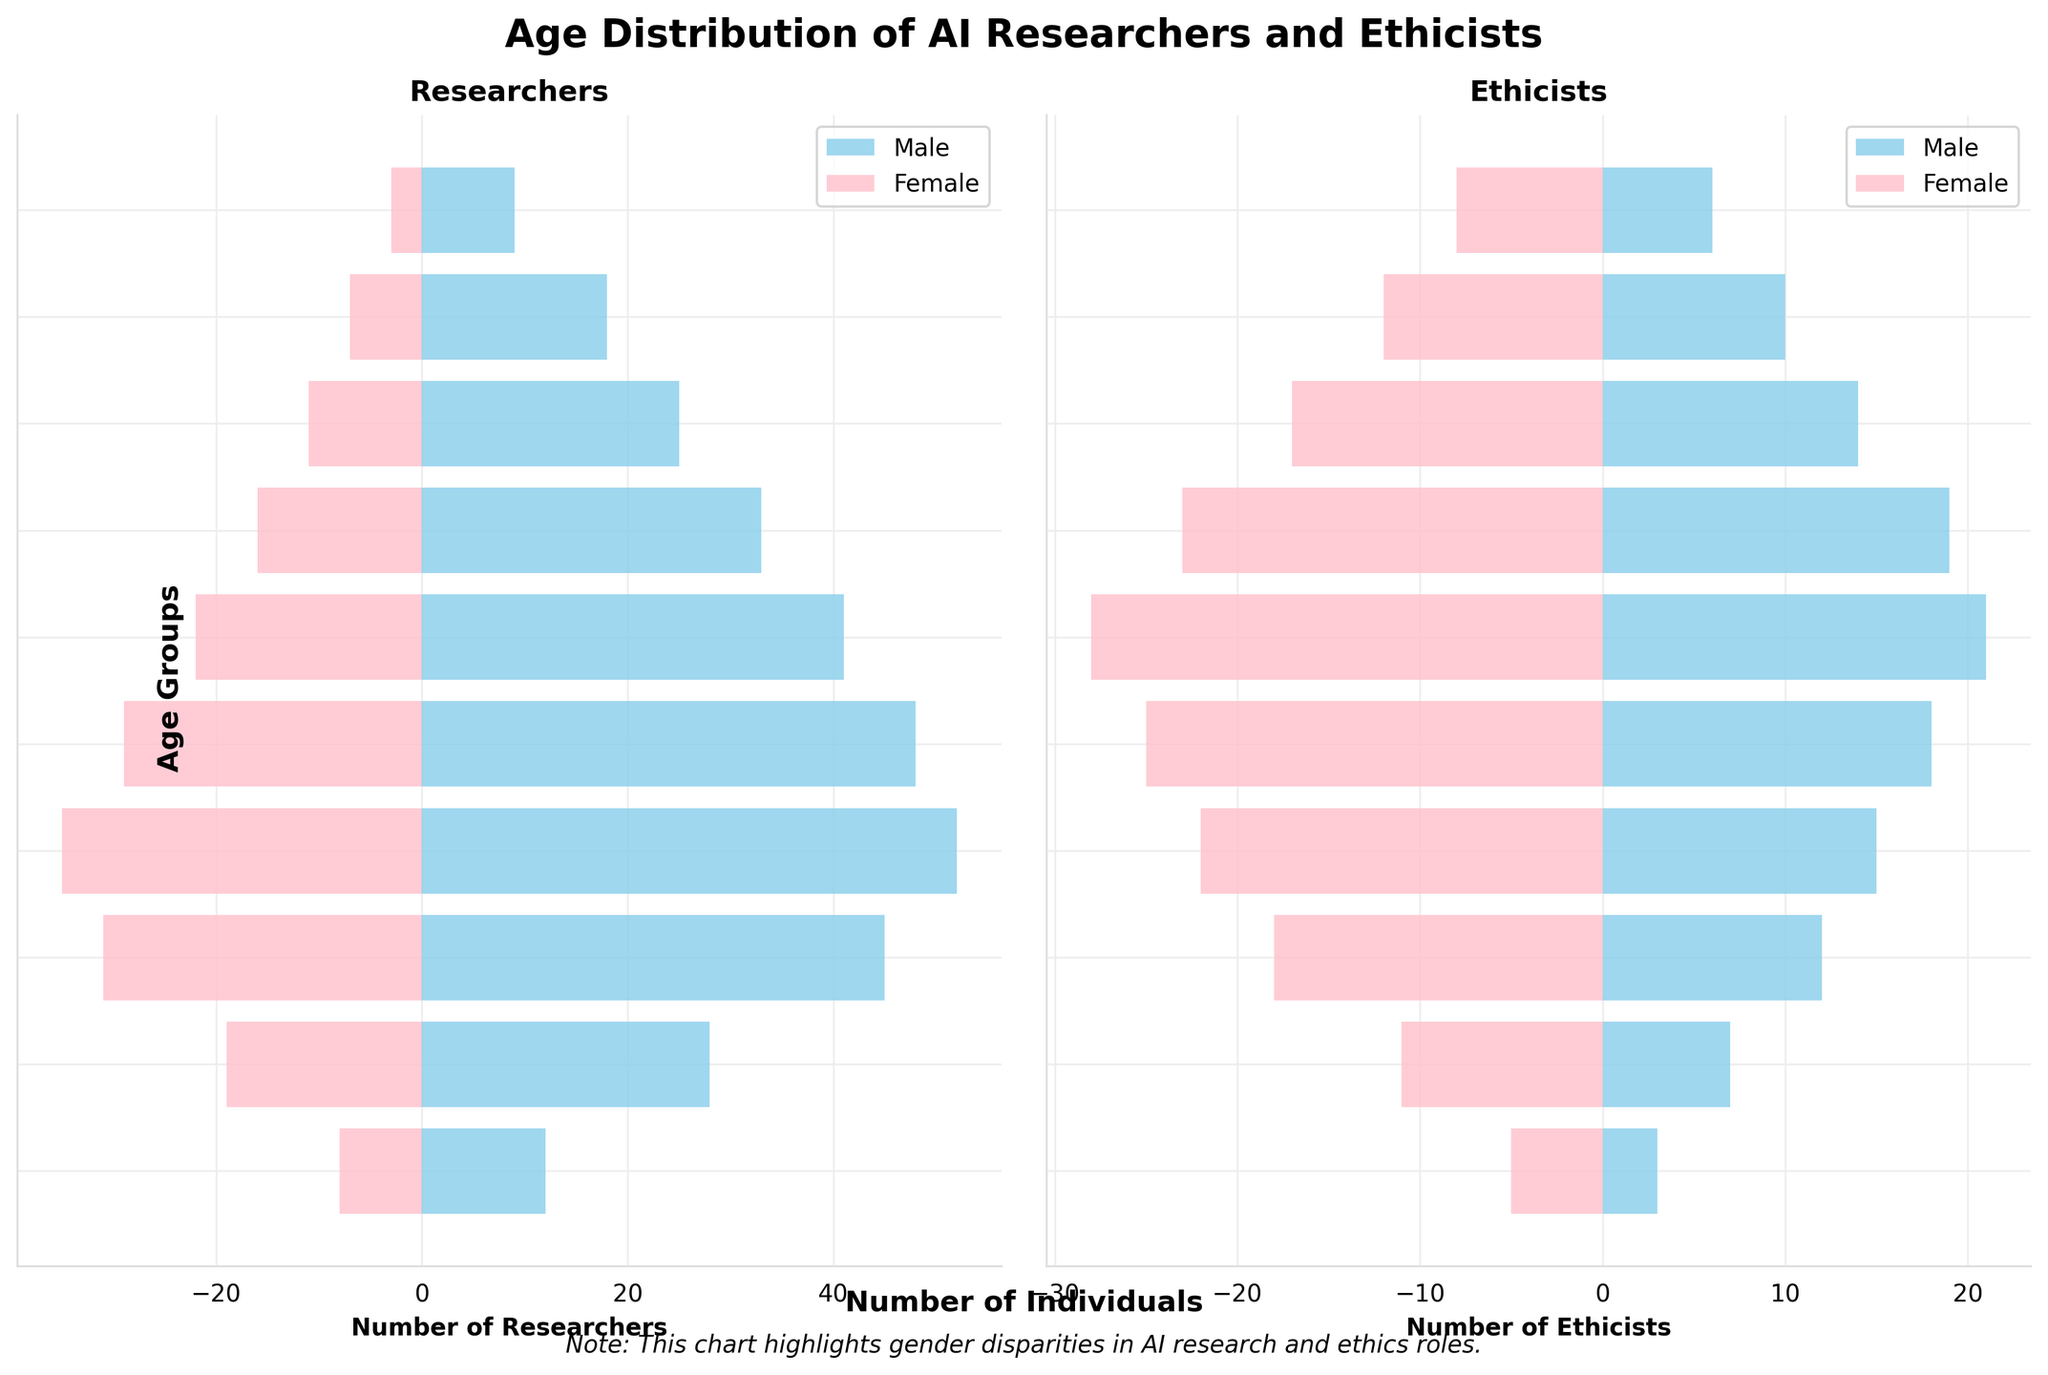What is the age group with the highest number of male researchers? The highest bar in the male researchers' section corresponds to the age group 35-39.
Answer: 35-39 In the 45-49 age group, how many more female ethicists are there compared to male ethicists? The bar for female ethicists shows 28 individuals, while the bar for male ethicists shows 21 individuals. The difference is 28 - 21.
Answer: 7 Compare the gender disparity between male and female researchers in the 30-34 age group. In the 30-34 age group, there are 45 male researchers and 31 female researchers. The disparity is 45 - 31.
Answer: 14 In which age group do female ethicists outnumber male ethicists the most? By comparing the bars of female and male ethicists across all age groups, the disparity is largest in the 45-49 age group where 28 female ethicists outnumber 21 male ethicists by 7.
Answer: 45-49 Which age group has an equal number of female ethicists and female researchers? The age group 35-39 has a bar of 22 for female ethicists and a bar of 35 for female researchers, so this age group does not meet the criterion. Rechecking other groups, none of them have equal counts either.
Answer: None What is the total number of AI researchers (both genders) in the 25-29 age group? Adding the bars for male and female researchers in the 25-29 age group gives 28 + 19.
Answer: 47 How does the number of male ethicists in the 20-24 age group compare to the number of male researchers in the same group? The bar for male ethicists shows 3 individuals, while the bar for male researchers shows 12 individuals.
Answer: Male researchers outnumber male ethicists by 9 Which gender has more ethicists in the 60-64 age group, and by how many? Comparing the bars for male and female ethicists, there are 10 male ethicists and 12 female ethicists. The difference is 12 - 10.
Answer: Female ethicists lead by 2 What is the total number of female AI researchers across all age groups? Summing up the bars for female researchers across all age groups: 8 + 19 + 31 + 35 + 29 + 22 + 16 + 11 + 7 + 3 = 181.
Answer: 181 In the age group 55-59, what is the ratio of male researchers to male ethicists? The bars show 25 male researchers and 14 male ethicists. The ratio is 25:14.
Answer: 25:14 